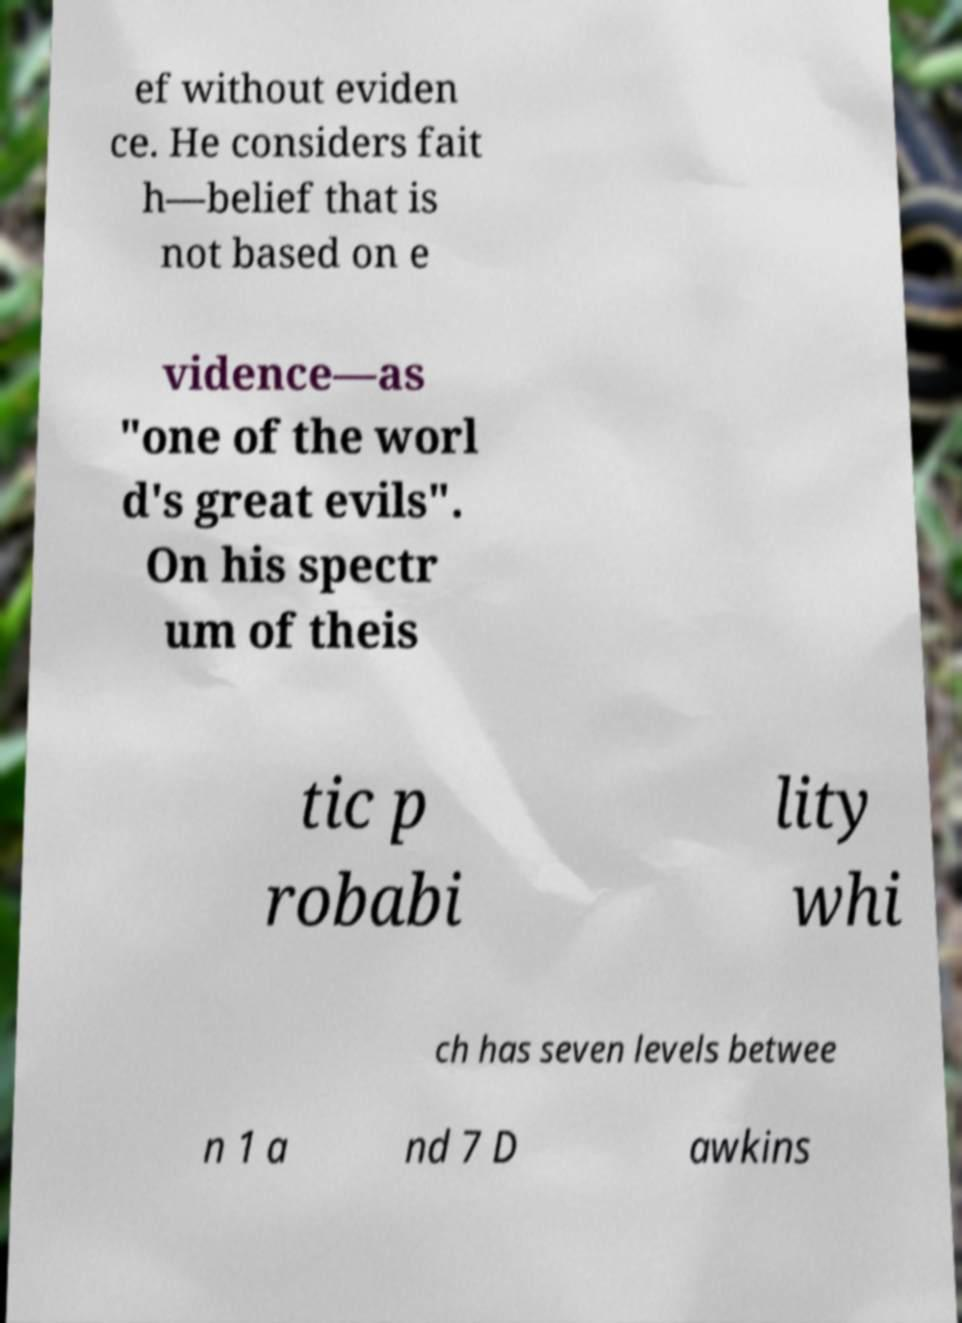I need the written content from this picture converted into text. Can you do that? ef without eviden ce. He considers fait h—belief that is not based on e vidence—as "one of the worl d's great evils". On his spectr um of theis tic p robabi lity whi ch has seven levels betwee n 1 a nd 7 D awkins 